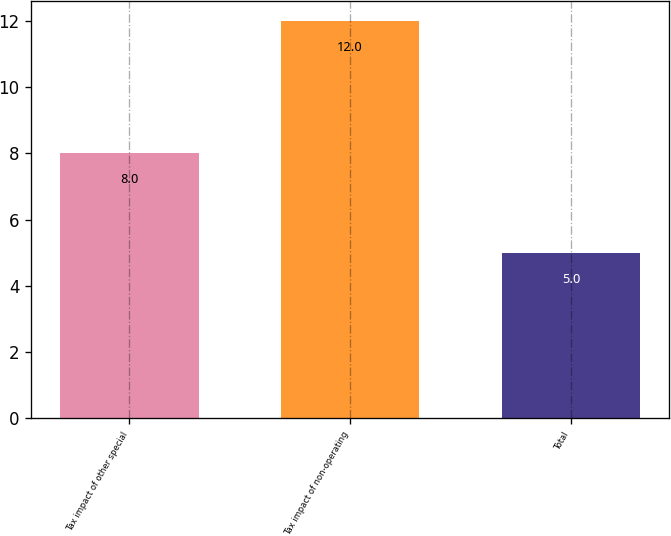Convert chart. <chart><loc_0><loc_0><loc_500><loc_500><bar_chart><fcel>Tax impact of other special<fcel>Tax impact of non-operating<fcel>Total<nl><fcel>8<fcel>12<fcel>5<nl></chart> 